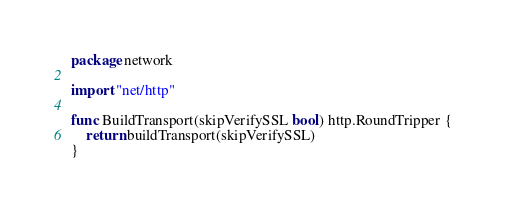<code> <loc_0><loc_0><loc_500><loc_500><_Go_>package network

import "net/http"

func BuildTransport(skipVerifySSL bool) http.RoundTripper {
	return buildTransport(skipVerifySSL)
}
</code> 